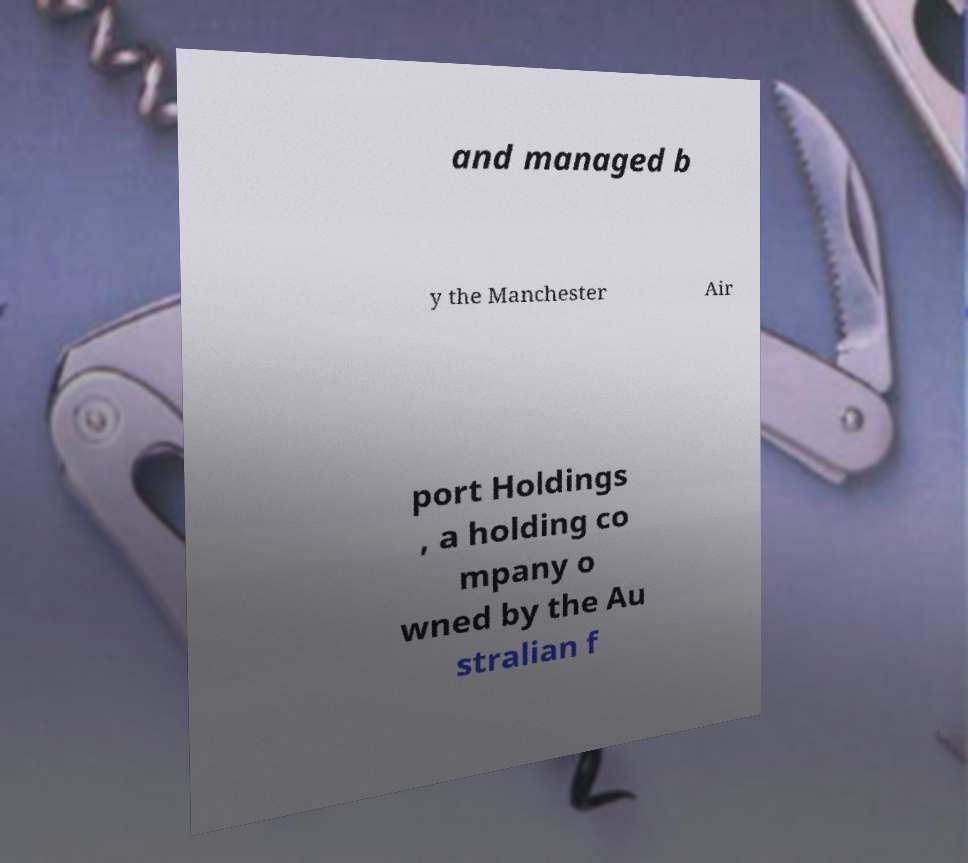Please read and relay the text visible in this image. What does it say? and managed b y the Manchester Air port Holdings , a holding co mpany o wned by the Au stralian f 